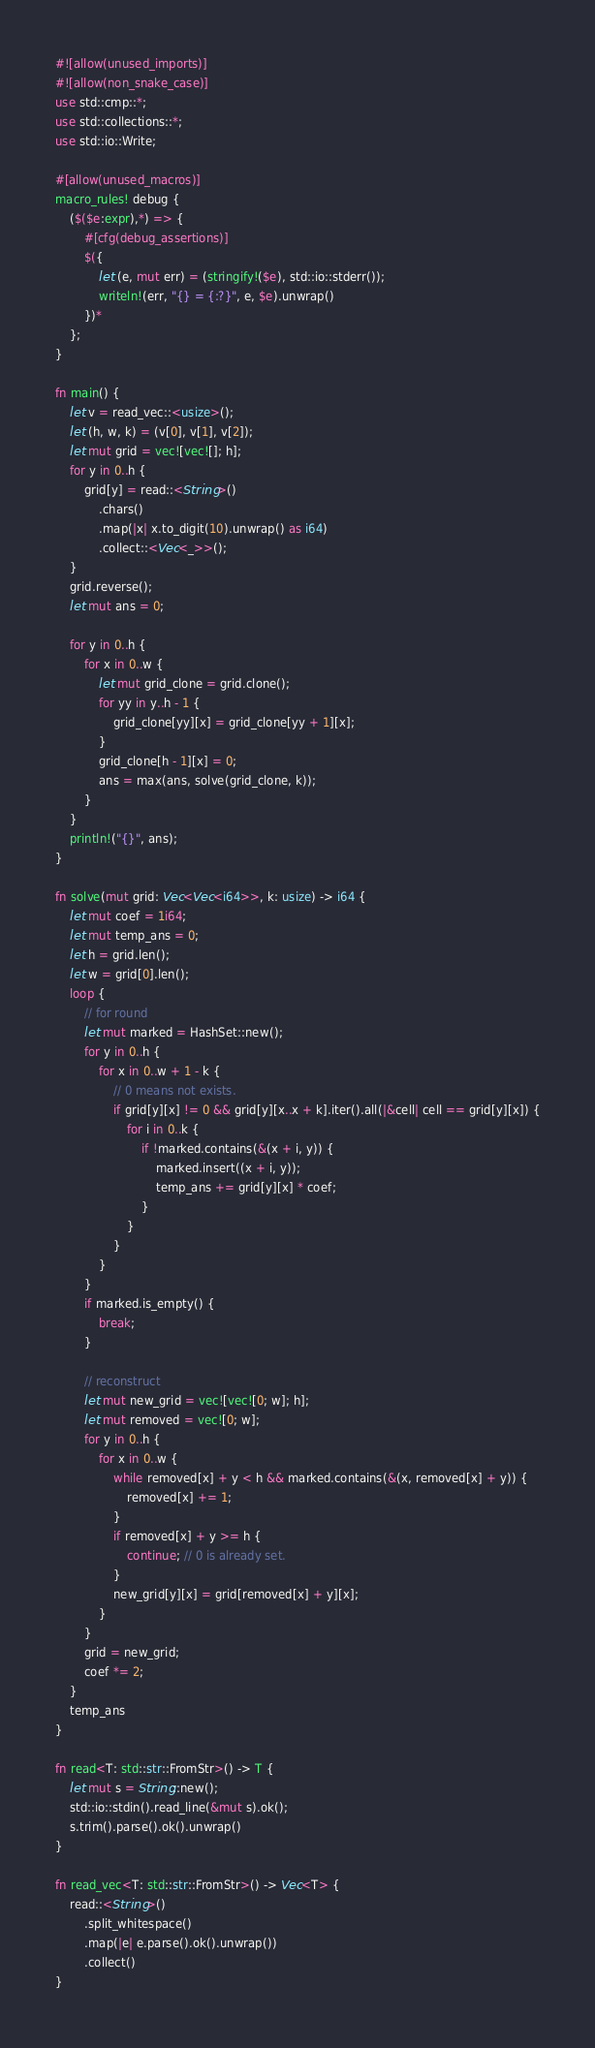<code> <loc_0><loc_0><loc_500><loc_500><_Rust_>#![allow(unused_imports)]
#![allow(non_snake_case)]
use std::cmp::*;
use std::collections::*;
use std::io::Write;

#[allow(unused_macros)]
macro_rules! debug {
    ($($e:expr),*) => {
        #[cfg(debug_assertions)]
        $({
            let (e, mut err) = (stringify!($e), std::io::stderr());
            writeln!(err, "{} = {:?}", e, $e).unwrap()
        })*
    };
}

fn main() {
    let v = read_vec::<usize>();
    let (h, w, k) = (v[0], v[1], v[2]);
    let mut grid = vec![vec![]; h];
    for y in 0..h {
        grid[y] = read::<String>()
            .chars()
            .map(|x| x.to_digit(10).unwrap() as i64)
            .collect::<Vec<_>>();
    }
    grid.reverse();
    let mut ans = 0;

    for y in 0..h {
        for x in 0..w {
            let mut grid_clone = grid.clone();
            for yy in y..h - 1 {
                grid_clone[yy][x] = grid_clone[yy + 1][x];
            }
            grid_clone[h - 1][x] = 0;
            ans = max(ans, solve(grid_clone, k));
        }
    }
    println!("{}", ans);
}

fn solve(mut grid: Vec<Vec<i64>>, k: usize) -> i64 {
    let mut coef = 1i64;
    let mut temp_ans = 0;
    let h = grid.len();
    let w = grid[0].len();
    loop {
        // for round
        let mut marked = HashSet::new();
        for y in 0..h {
            for x in 0..w + 1 - k {
                // 0 means not exists.
                if grid[y][x] != 0 && grid[y][x..x + k].iter().all(|&cell| cell == grid[y][x]) {
                    for i in 0..k {
                        if !marked.contains(&(x + i, y)) {
                            marked.insert((x + i, y));
                            temp_ans += grid[y][x] * coef;
                        }
                    }
                }
            }
        }
        if marked.is_empty() {
            break;
        }

        // reconstruct
        let mut new_grid = vec![vec![0; w]; h];
        let mut removed = vec![0; w];
        for y in 0..h {
            for x in 0..w {
                while removed[x] + y < h && marked.contains(&(x, removed[x] + y)) {
                    removed[x] += 1;
                }
                if removed[x] + y >= h {
                    continue; // 0 is already set.
                }
                new_grid[y][x] = grid[removed[x] + y][x];
            }
        }
        grid = new_grid;
        coef *= 2;
    }
    temp_ans
}

fn read<T: std::str::FromStr>() -> T {
    let mut s = String::new();
    std::io::stdin().read_line(&mut s).ok();
    s.trim().parse().ok().unwrap()
}

fn read_vec<T: std::str::FromStr>() -> Vec<T> {
    read::<String>()
        .split_whitespace()
        .map(|e| e.parse().ok().unwrap())
        .collect()
}
</code> 